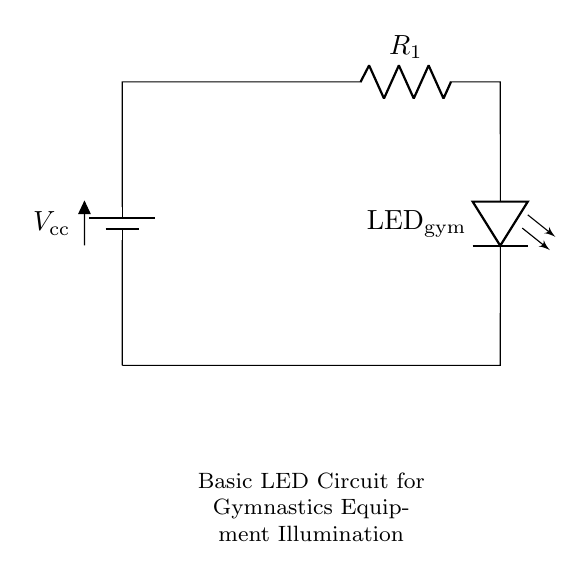What is the type of power source used in this circuit? The power source is a battery, specifically a nine-volt battery as indicated by the label.
Answer: nine-volt battery What is the resistance value of the resistor in this circuit? The resistor is labeled with a value of 470 ohms, which is specified next to its symbol in the diagram.
Answer: 470 ohms How many components are connected in this circuit? There are four components: one battery, one resistor, one LED, and one connecting wire (short). These are counted by identifying the different symbols in the circuit.
Answer: four What type of LED is used in the circuit? The LED is labeled "LED gym," indicating it is specifically designated for illuminating gymnastics equipment.
Answer: LED gym What is the purpose of the resistor in this circuit? The resistor limits the current flowing through the LED, which is crucial for preventing damage to the LED by ensuring that the current stays within safe levels.
Answer: limit current If the voltage of the power source is increased, what effect would that have on the LED? Increasing the voltage can lead to higher current through the LED, potentially exceeding its rated current, which could damage the LED. Thus, careful consideration of the voltage is essential.
Answer: potential damage What is the main function of this circuit? The main function of the circuit is to provide illumination for gymnastics equipment during night training sessions, as indicated in the title below the circuit.
Answer: illuminate gymnastics equipment 